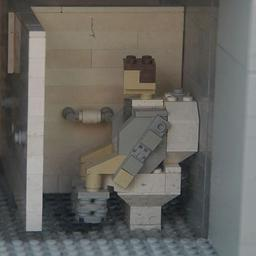How does this Lego sculpture challenge our usual perceptions of privacy and personal space? This Lego sculpture subtly challenges common perceptions by bringing a private moment into a public art form. Using Lego, an object associated with openness and play, to depict a private setting like a bathroom brings a layered irony, engaging viewers to rethink privacy norms in increasingly public lives. 